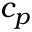Convert formula to latex. <formula><loc_0><loc_0><loc_500><loc_500>c _ { p }</formula> 